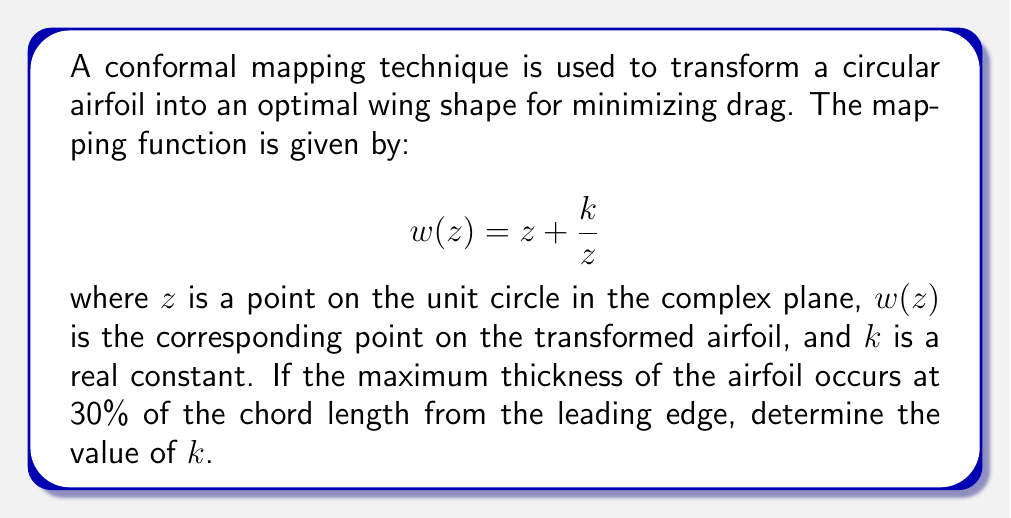Can you answer this question? Let's approach this step-by-step:

1) The point of maximum thickness on the airfoil corresponds to the point on the unit circle where the imaginary part of $w(z)$ is maximized.

2) Let $z = e^{i\theta}$ (a point on the unit circle). Then:

   $$w(z) = e^{i\theta} + ke^{-i\theta}$$

3) The imaginary part of $w(z)$ is:

   $$\text{Im}(w(z)) = \sin\theta - k\sin\theta = (1-k)\sin\theta$$

4) To find the maximum, we differentiate with respect to $\theta$ and set to zero:

   $$\frac{d}{d\theta}[(1-k)\sin\theta] = (1-k)\cos\theta = 0$$

5) This occurs when $\cos\theta = 0$, or when $\theta = \frac{\pi}{2}$.

6) At this point, $z = i$, and the real part of $w(z)$ represents the position along the chord:

   $$\text{Re}(w(i)) = 0 + k = k$$

7) We're told this occurs at 30% of the chord length. The total chord length is the distance from $w(1)$ to $w(-1)$:

   $$\text{Chord length} = (1+k) - (-1-k) = 2+2k$$

8) Therefore:

   $$\frac{k}{2+2k} = 0.3$$

9) Solving this equation:

   $$k = 0.3(2+2k)$$
   $$k = 0.6 + 0.6k$$
   $$0.4k = 0.6$$
   $$k = 1.5$$
Answer: $k = 1.5$ 